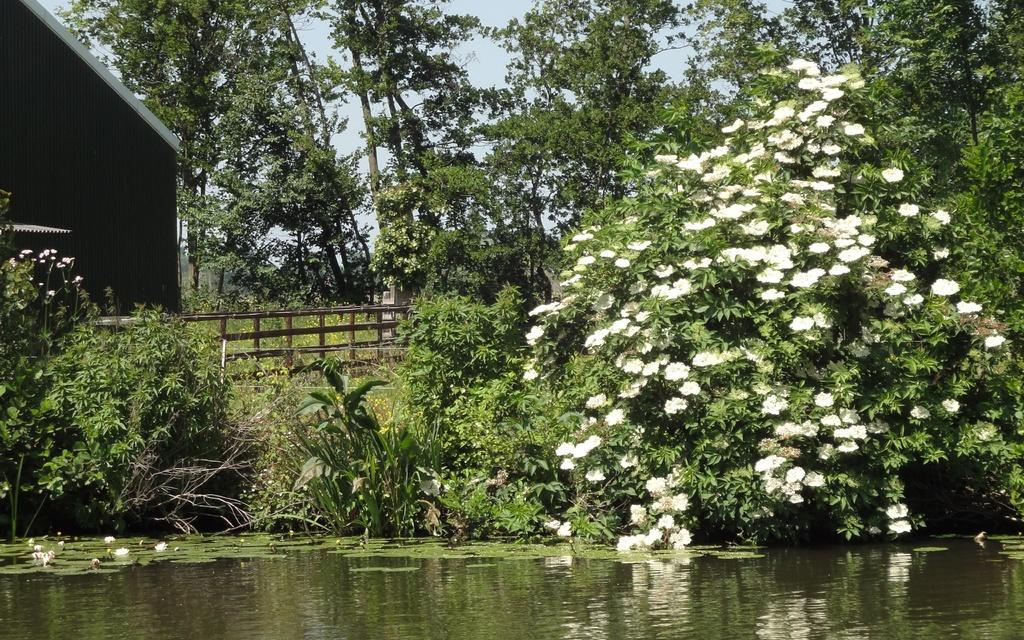What is present at the bottom of the image? There is water at the bottom of the image. What structure can be seen on the left side of the image? There is a shed on the left side of the image. What type of vegetation is visible in the background of the image? There are trees in the background of the image. What else can be seen in the background of the image? The sky is visible in the background of the image. Can you see any dinosaurs playing with a marble on their tongue in the image? There are no dinosaurs or marbles present in the image, and tongues are not visible either. 